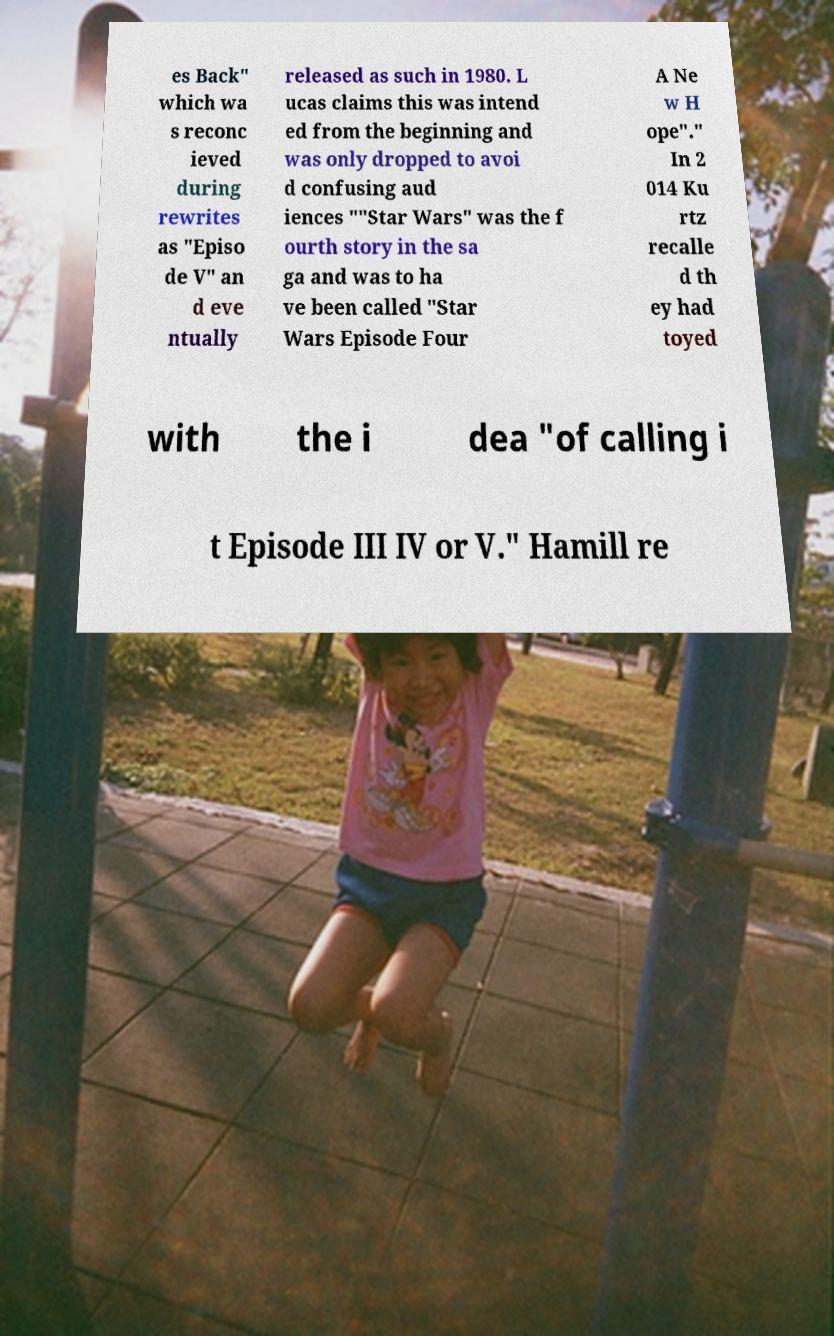I need the written content from this picture converted into text. Can you do that? es Back" which wa s reconc ieved during rewrites as "Episo de V" an d eve ntually released as such in 1980. L ucas claims this was intend ed from the beginning and was only dropped to avoi d confusing aud iences ""Star Wars" was the f ourth story in the sa ga and was to ha ve been called "Star Wars Episode Four A Ne w H ope"." In 2 014 Ku rtz recalle d th ey had toyed with the i dea "of calling i t Episode III IV or V." Hamill re 